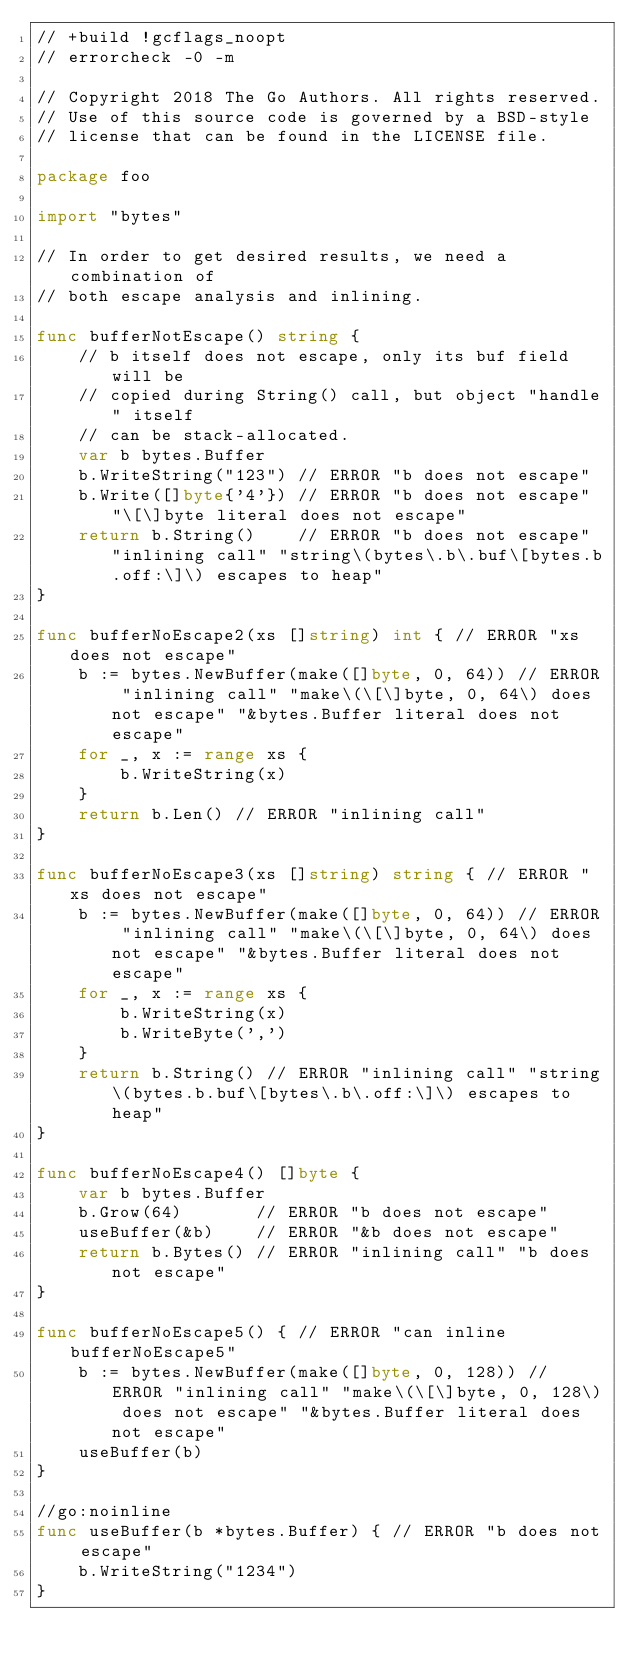<code> <loc_0><loc_0><loc_500><loc_500><_Go_>// +build !gcflags_noopt
// errorcheck -0 -m

// Copyright 2018 The Go Authors. All rights reserved.
// Use of this source code is governed by a BSD-style
// license that can be found in the LICENSE file.

package foo

import "bytes"

// In order to get desired results, we need a combination of
// both escape analysis and inlining.

func bufferNotEscape() string {
	// b itself does not escape, only its buf field will be
	// copied during String() call, but object "handle" itself
	// can be stack-allocated.
	var b bytes.Buffer
	b.WriteString("123") // ERROR "b does not escape"
	b.Write([]byte{'4'}) // ERROR "b does not escape" "\[\]byte literal does not escape"
	return b.String()    // ERROR "b does not escape" "inlining call" "string\(bytes\.b\.buf\[bytes.b.off:\]\) escapes to heap"
}

func bufferNoEscape2(xs []string) int { // ERROR "xs does not escape"
	b := bytes.NewBuffer(make([]byte, 0, 64)) // ERROR "inlining call" "make\(\[\]byte, 0, 64\) does not escape" "&bytes.Buffer literal does not escape"
	for _, x := range xs {
		b.WriteString(x)
	}
	return b.Len() // ERROR "inlining call"
}

func bufferNoEscape3(xs []string) string { // ERROR "xs does not escape"
	b := bytes.NewBuffer(make([]byte, 0, 64)) // ERROR "inlining call" "make\(\[\]byte, 0, 64\) does not escape" "&bytes.Buffer literal does not escape"
	for _, x := range xs {
		b.WriteString(x)
		b.WriteByte(',')
	}
	return b.String() // ERROR "inlining call" "string\(bytes.b.buf\[bytes\.b\.off:\]\) escapes to heap"
}

func bufferNoEscape4() []byte {
	var b bytes.Buffer
	b.Grow(64)       // ERROR "b does not escape"
	useBuffer(&b)    // ERROR "&b does not escape"
	return b.Bytes() // ERROR "inlining call" "b does not escape"
}

func bufferNoEscape5() { // ERROR "can inline bufferNoEscape5"
	b := bytes.NewBuffer(make([]byte, 0, 128)) // ERROR "inlining call" "make\(\[\]byte, 0, 128\) does not escape" "&bytes.Buffer literal does not escape"
	useBuffer(b)
}

//go:noinline
func useBuffer(b *bytes.Buffer) { // ERROR "b does not escape"
	b.WriteString("1234")
}
</code> 